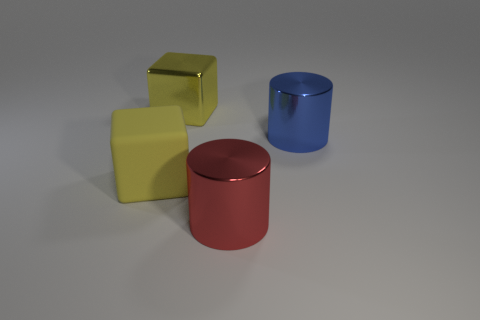Add 2 yellow objects. How many objects exist? 6 Subtract 1 blocks. How many blocks are left? 1 Subtract all purple cubes. Subtract all gray balls. How many cubes are left? 2 Subtract all cyan blocks. How many red cylinders are left? 1 Add 1 yellow metal cylinders. How many yellow metal cylinders exist? 1 Subtract 0 purple blocks. How many objects are left? 4 Subtract all large cyan rubber things. Subtract all large matte objects. How many objects are left? 3 Add 1 large yellow metallic things. How many large yellow metallic things are left? 2 